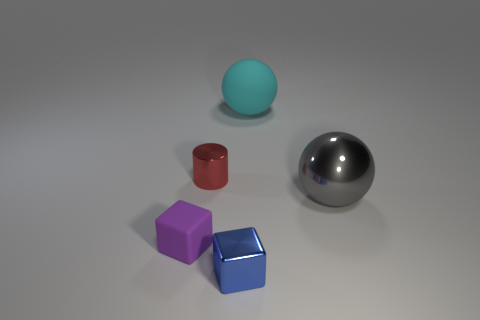How many other rubber spheres are the same color as the big matte ball?
Your response must be concise. 0. What number of purple matte blocks are there?
Your response must be concise. 1. What number of tiny cyan cylinders are made of the same material as the gray sphere?
Offer a very short reply. 0. There is another thing that is the same shape as the big cyan thing; what is its size?
Offer a terse response. Large. What material is the small blue object?
Keep it short and to the point. Metal. What material is the small cube on the left side of the metallic object in front of the tiny thing that is on the left side of the tiny red thing?
Provide a short and direct response. Rubber. Is the number of blue things the same as the number of large blue metallic cylinders?
Provide a short and direct response. No. Are there any other things that are the same shape as the gray metallic object?
Keep it short and to the point. Yes. What color is the large matte thing that is the same shape as the gray metallic thing?
Give a very brief answer. Cyan. There is a cube to the left of the metallic cube; does it have the same color as the small thing behind the metal sphere?
Provide a succinct answer. No. 